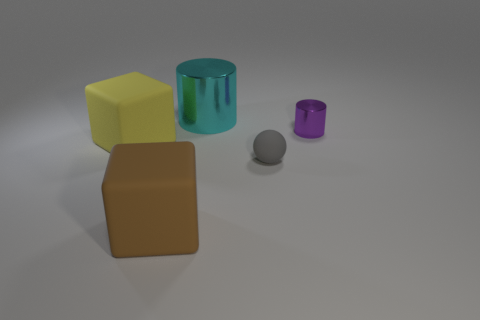Add 3 gray metal balls. How many objects exist? 8 Add 5 cyan cylinders. How many cyan cylinders exist? 6 Subtract 0 yellow cylinders. How many objects are left? 5 Subtract all spheres. How many objects are left? 4 Subtract all large metal cylinders. Subtract all small brown blocks. How many objects are left? 4 Add 2 tiny rubber things. How many tiny rubber things are left? 3 